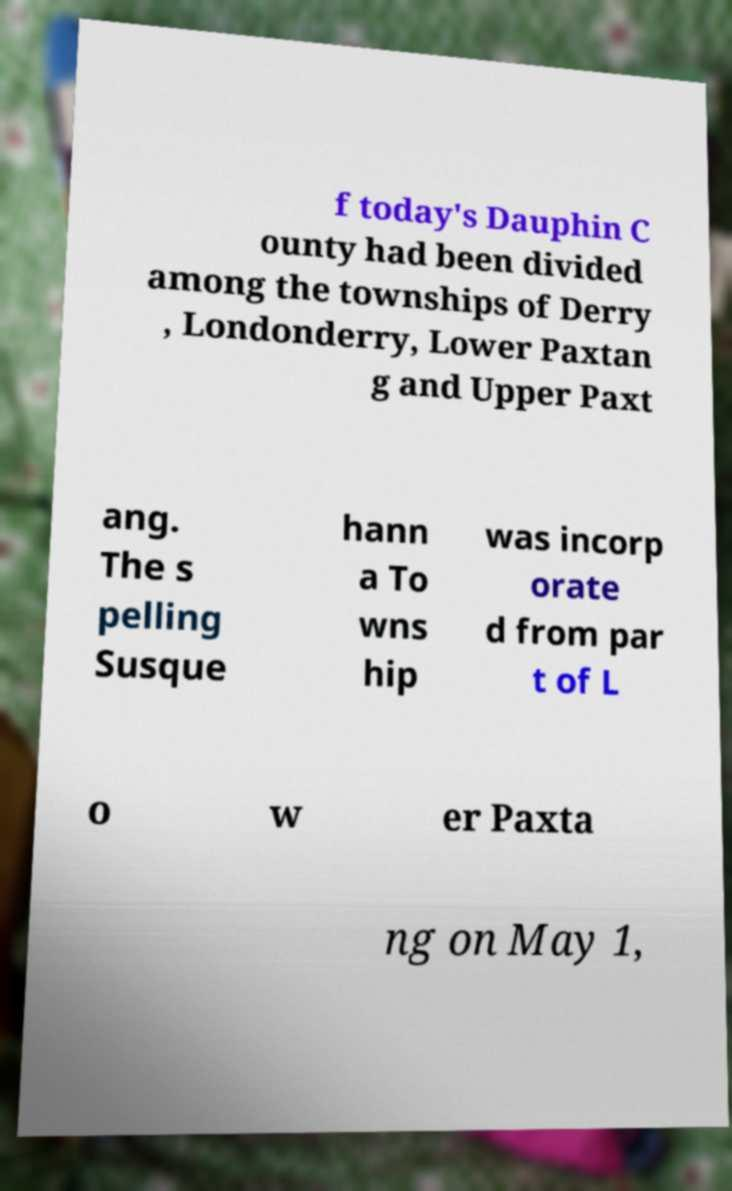Can you accurately transcribe the text from the provided image for me? f today's Dauphin C ounty had been divided among the townships of Derry , Londonderry, Lower Paxtan g and Upper Paxt ang. The s pelling Susque hann a To wns hip was incorp orate d from par t of L o w er Paxta ng on May 1, 